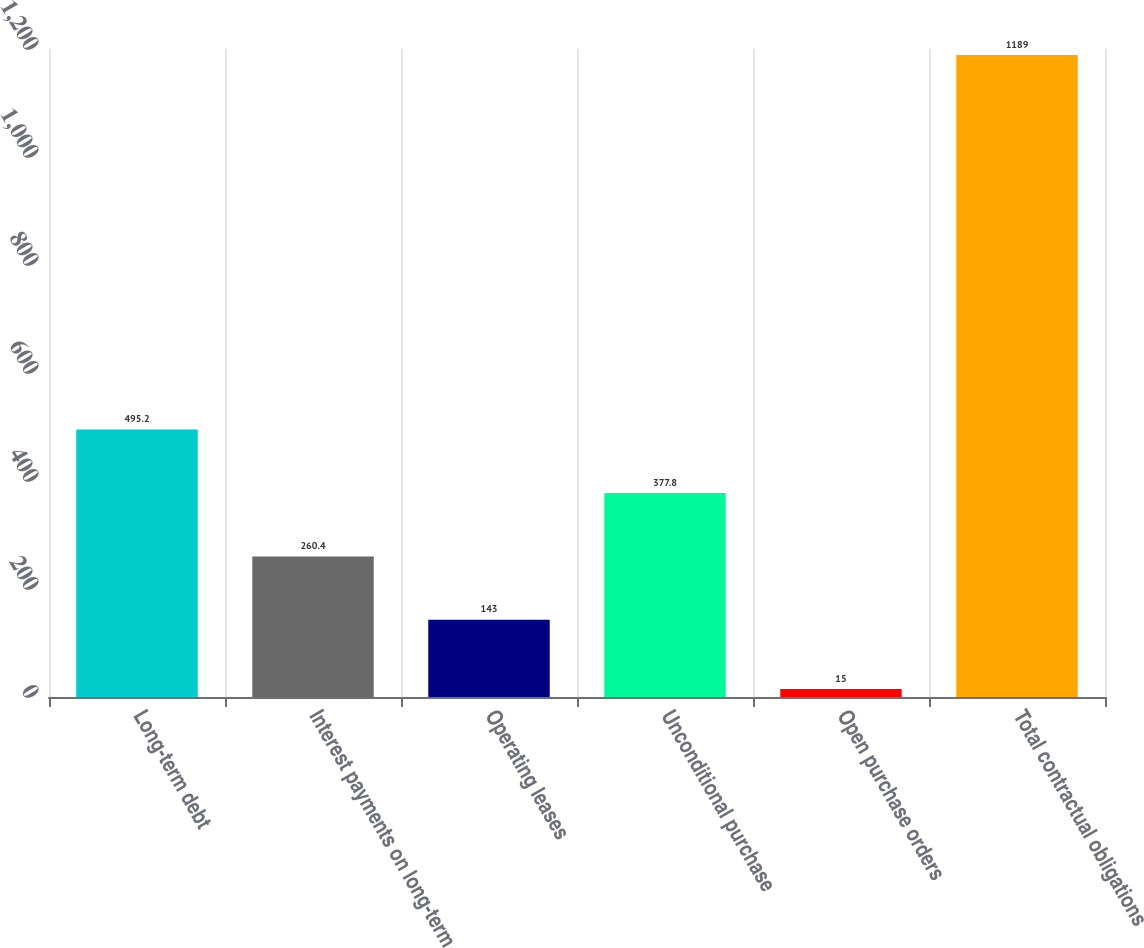Convert chart to OTSL. <chart><loc_0><loc_0><loc_500><loc_500><bar_chart><fcel>Long-term debt<fcel>Interest payments on long-term<fcel>Operating leases<fcel>Unconditional purchase<fcel>Open purchase orders<fcel>Total contractual obligations<nl><fcel>495.2<fcel>260.4<fcel>143<fcel>377.8<fcel>15<fcel>1189<nl></chart> 